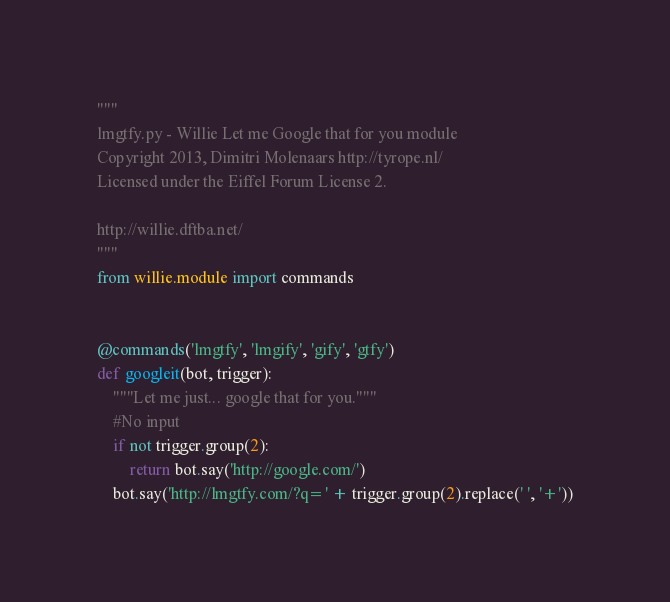<code> <loc_0><loc_0><loc_500><loc_500><_Python_>"""
lmgtfy.py - Willie Let me Google that for you module
Copyright 2013, Dimitri Molenaars http://tyrope.nl/
Licensed under the Eiffel Forum License 2.

http://willie.dftba.net/
"""
from willie.module import commands


@commands('lmgtfy', 'lmgify', 'gify', 'gtfy')
def googleit(bot, trigger):
    """Let me just... google that for you."""
    #No input
    if not trigger.group(2):
        return bot.say('http://google.com/')
    bot.say('http://lmgtfy.com/?q=' + trigger.group(2).replace(' ', '+'))
</code> 